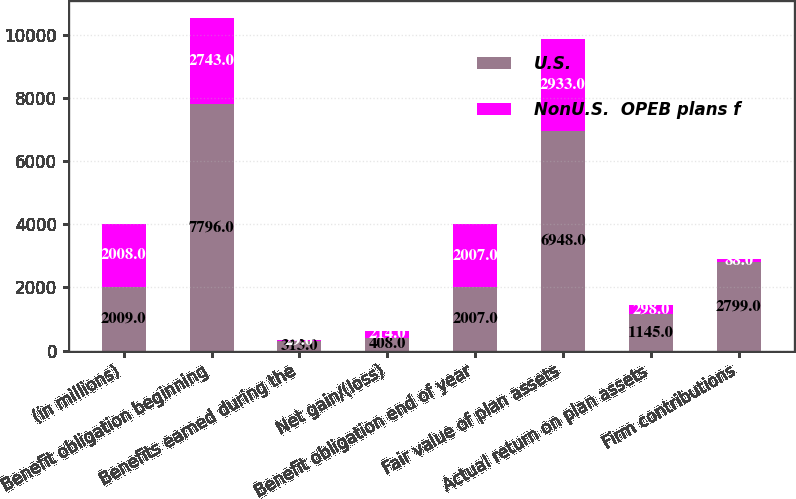<chart> <loc_0><loc_0><loc_500><loc_500><stacked_bar_chart><ecel><fcel>(in millions)<fcel>Benefit obligation beginning<fcel>Benefits earned during the<fcel>Net gain/(loss)<fcel>Benefit obligation end of year<fcel>Fair value of plan assets<fcel>Actual return on plan assets<fcel>Firm contributions<nl><fcel>U.S.<fcel>2009<fcel>7796<fcel>313<fcel>408<fcel>2007<fcel>6948<fcel>1145<fcel>2799<nl><fcel>NonU.S.  OPEB plans f<fcel>2008<fcel>2743<fcel>29<fcel>214<fcel>2007<fcel>2933<fcel>298<fcel>88<nl></chart> 